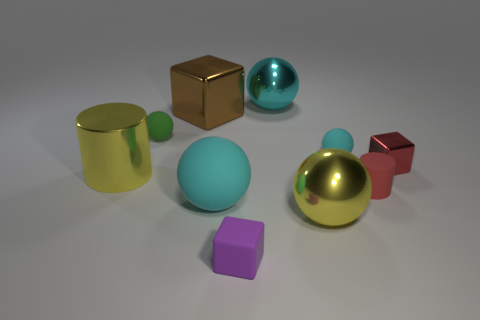Does the tiny cylinder have the same color as the small metal cube?
Provide a short and direct response. Yes. The shiny object that is the same color as the big rubber thing is what size?
Your answer should be compact. Large. What is the size of the cyan thing that is made of the same material as the large brown cube?
Ensure brevity in your answer.  Large. What is the size of the yellow object that is the same shape as the large cyan shiny thing?
Your response must be concise. Large. Is the color of the small cylinder the same as the tiny cube behind the metallic cylinder?
Provide a succinct answer. Yes. What number of large balls are behind the cyan matte sphere that is left of the large cyan metallic thing?
Your answer should be compact. 1. There is a cylinder on the right side of the cylinder left of the tiny cyan rubber object; what color is it?
Your answer should be very brief. Red. What is the thing that is both left of the big matte thing and behind the small green rubber sphere made of?
Give a very brief answer. Metal. Are there any other matte things that have the same shape as the tiny cyan thing?
Your answer should be compact. Yes. There is a large cyan thing in front of the green ball; is it the same shape as the big cyan metal thing?
Offer a terse response. Yes. 